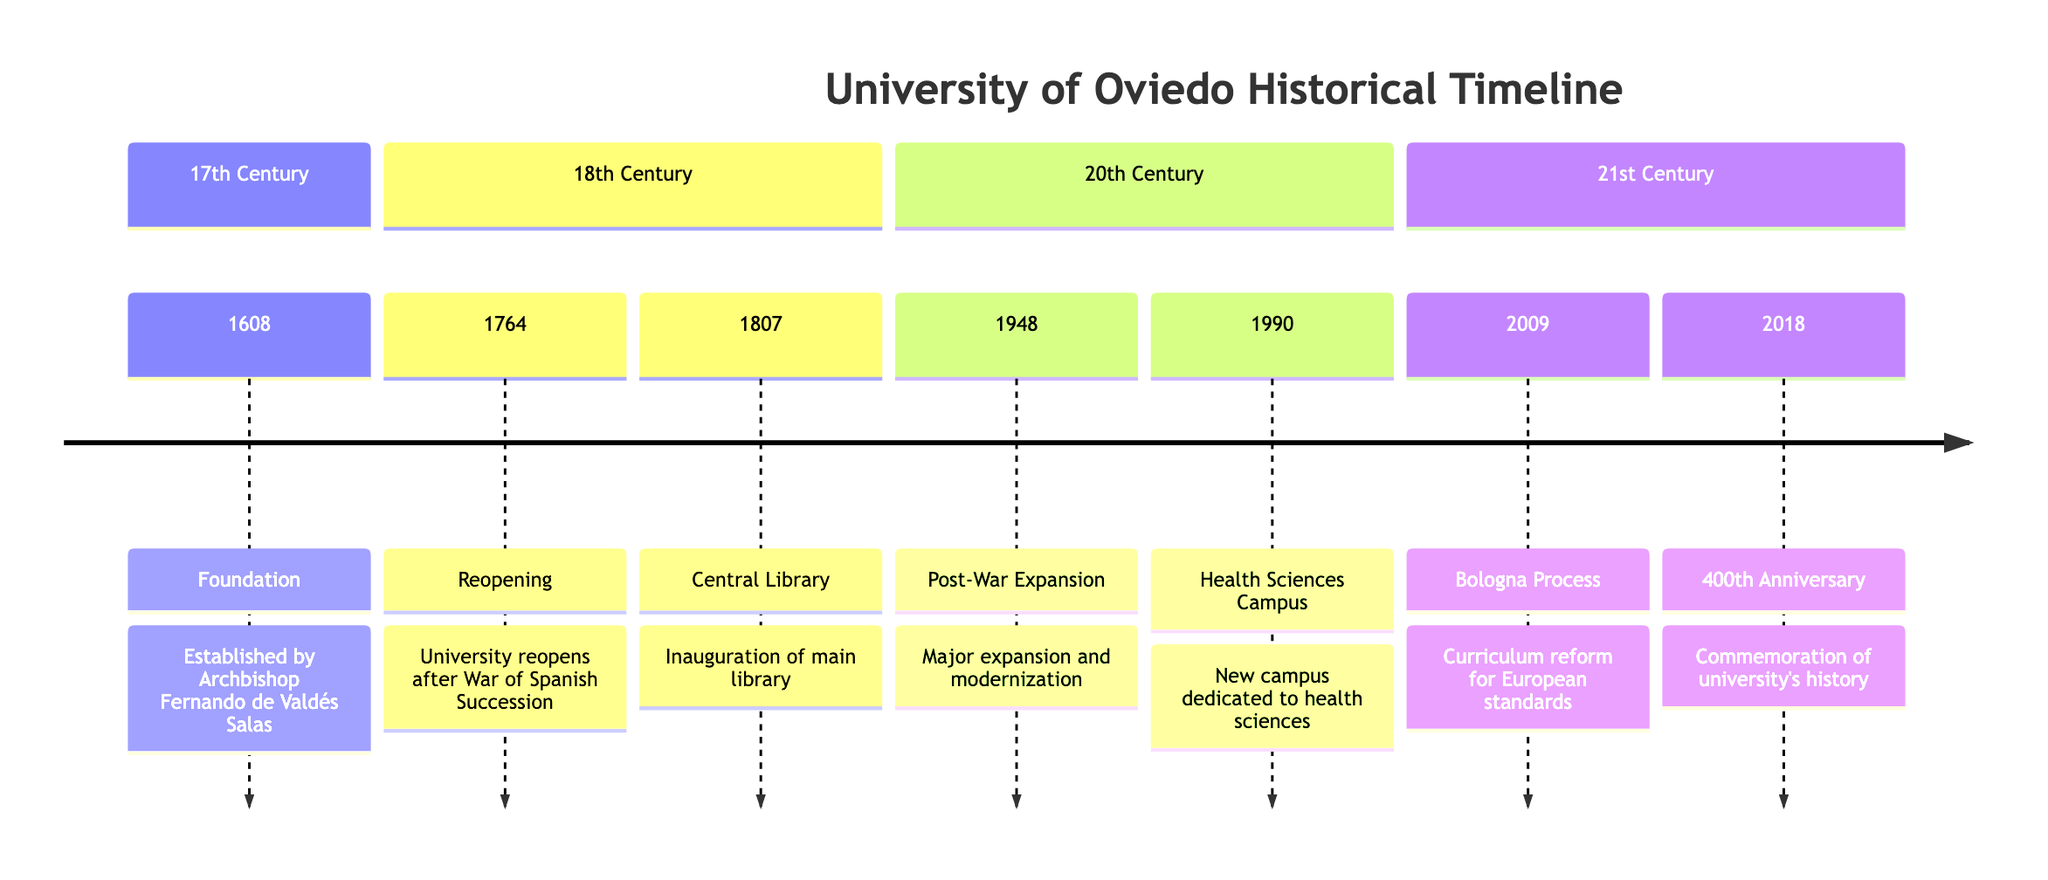What year was the University of Oviedo founded? According to the timeline, the University of Oviedo was founded in 1608.
Answer: 1608 What significant event occurred in 1764 at the University of Oviedo? The timeline indicates that in 1764, the University of Oviedo reopened after the War of Spanish Succession.
Answer: Reopening How many milestones are listed in the 20th Century section? There are a total of two milestones listed under the 20th Century section: one for 1948 and another for 1990.
Answer: 2 What milestone took place in 2009? The timeline shows that in 2009, the Bologna Process was implemented, indicating a curriculum reform for European standards.
Answer: Bologna Process Which century saw the commemoration of the University's 400th anniversary? According to the timeline, the 400th anniversary was commemorated in 2018, which falls in the 21st Century.
Answer: 21st Century What was inaugurated in 1807? The timeline states that the main library was inaugurated in 1807.
Answer: Central Library What major expansion occurred in 1948? In 1948, the University underwent a major expansion and modernization effort, as indicated by the timeline.
Answer: Post-War Expansion Which two events in the timeline are related to library services? The events that relate to library services are the inauguration of the main library in 1807 and the expansion in 1948 that included modernization, thereby improving library facilities.
Answer: Central Library, Post-War Expansion 